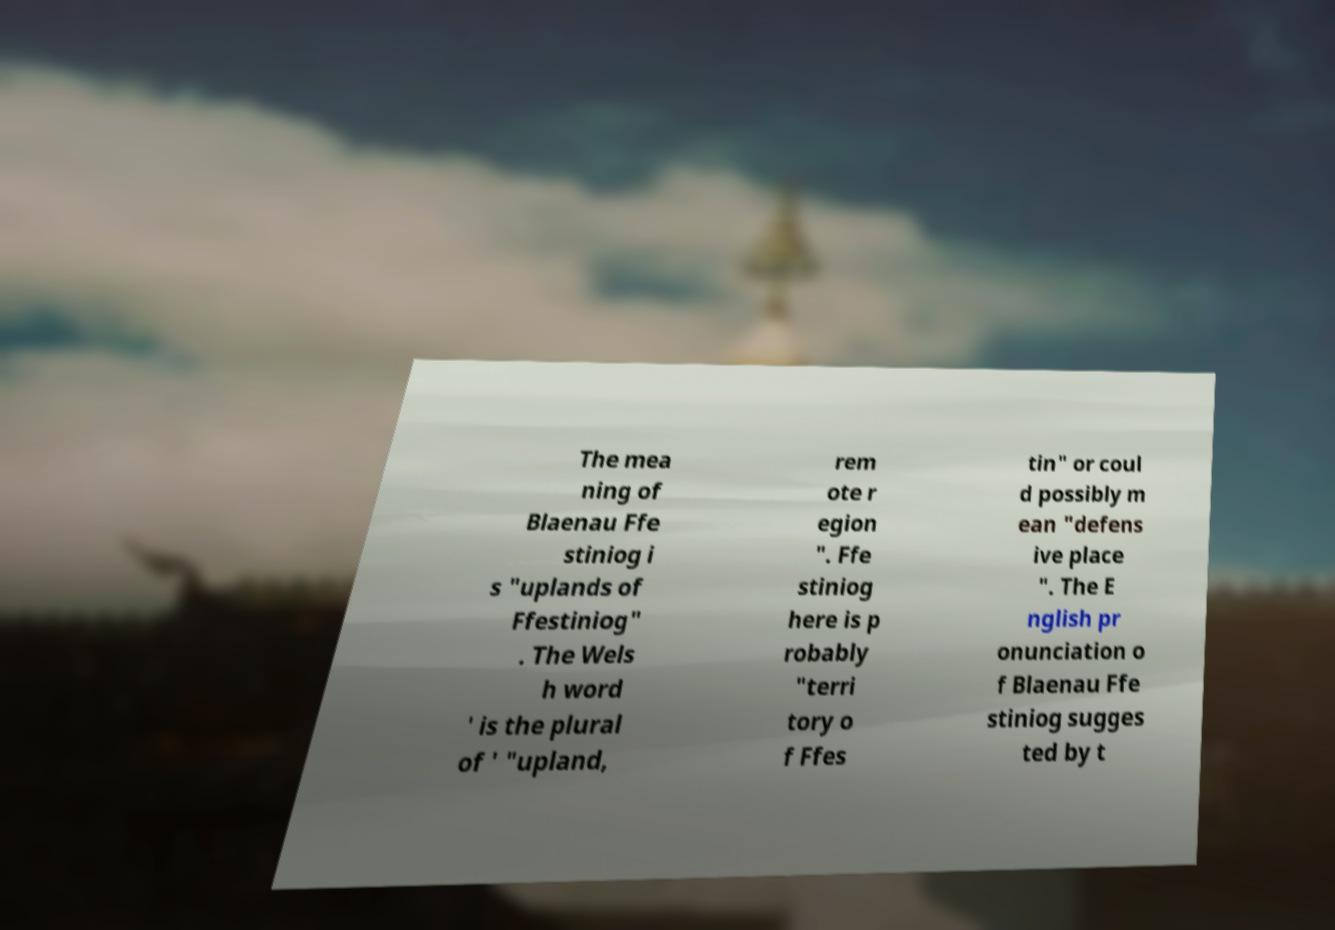Please identify and transcribe the text found in this image. The mea ning of Blaenau Ffe stiniog i s "uplands of Ffestiniog" . The Wels h word ' is the plural of ' "upland, rem ote r egion ". Ffe stiniog here is p robably "terri tory o f Ffes tin" or coul d possibly m ean "defens ive place ". The E nglish pr onunciation o f Blaenau Ffe stiniog sugges ted by t 